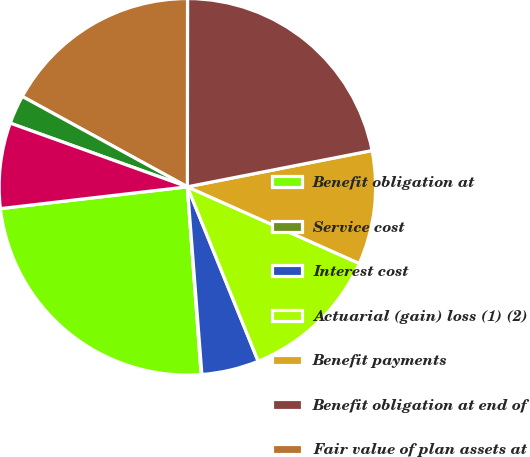Convert chart. <chart><loc_0><loc_0><loc_500><loc_500><pie_chart><fcel>Benefit obligation at<fcel>Service cost<fcel>Interest cost<fcel>Actuarial (gain) loss (1) (2)<fcel>Benefit payments<fcel>Benefit obligation at end of<fcel>Fair value of plan assets at<fcel>Actual return on plan assets<fcel>Employer contributions<nl><fcel>24.32%<fcel>0.06%<fcel>4.91%<fcel>12.19%<fcel>9.76%<fcel>21.9%<fcel>17.04%<fcel>2.48%<fcel>7.34%<nl></chart> 